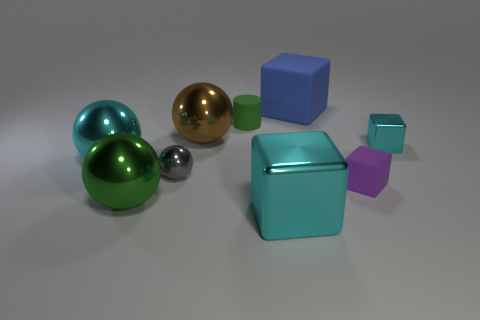How would you describe the lighting and shadows in this scene? The lighting appears soft and diffused, creating gentle shadows on the ground to the right of each object. Each object casts a shadow consistent with a light source above and slightly to the right. The nature of the shadows and highlights on the surfaces of the objects suggests an internal studio light setup. 